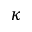Convert formula to latex. <formula><loc_0><loc_0><loc_500><loc_500>\kappa</formula> 